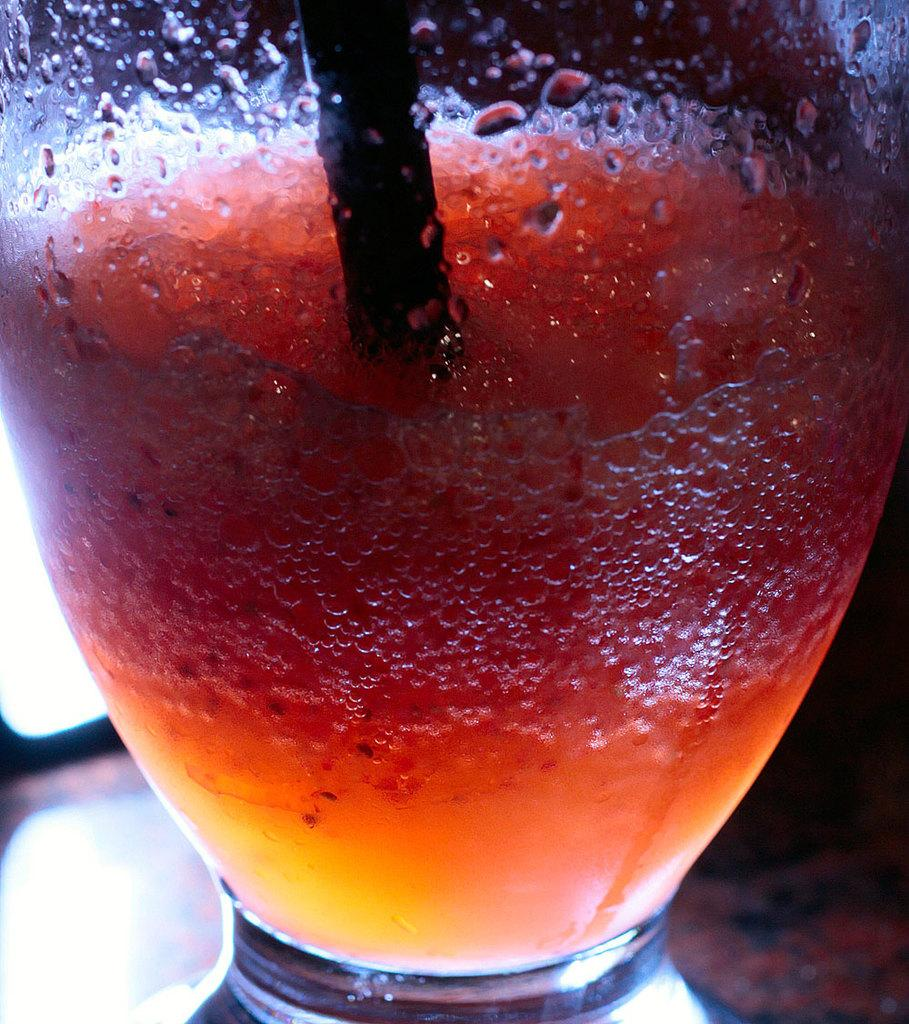What is contained in the glass that is visible in the image? There is a drink in a glass in the image. What type of cap is the jellyfish wearing in the image? There is no jellyfish or cap present in the image. The image only contains a glass with a drink in it. 